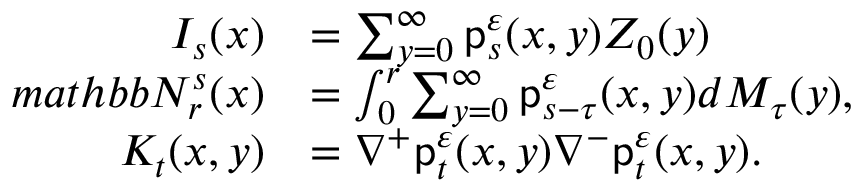Convert formula to latex. <formula><loc_0><loc_0><loc_500><loc_500>\begin{array} { r l } { I _ { s } ( x ) } & { = \sum _ { y = 0 } ^ { \infty } p _ { s } ^ { \varepsilon } ( x , y ) Z _ { 0 } ( y ) } \\ { m a t h b b N _ { r } ^ { s } ( x ) } & { = \int _ { 0 } ^ { r } \sum _ { y = 0 } ^ { \infty } p _ { s - \tau } ^ { \varepsilon } ( x , y ) d M _ { \tau } ( y ) , } \\ { K _ { t } ( x , y ) } & { = \nabla ^ { + } p _ { t } ^ { \varepsilon } ( x , y ) \nabla ^ { - } p _ { t } ^ { \varepsilon } ( x , y ) . } \end{array}</formula> 